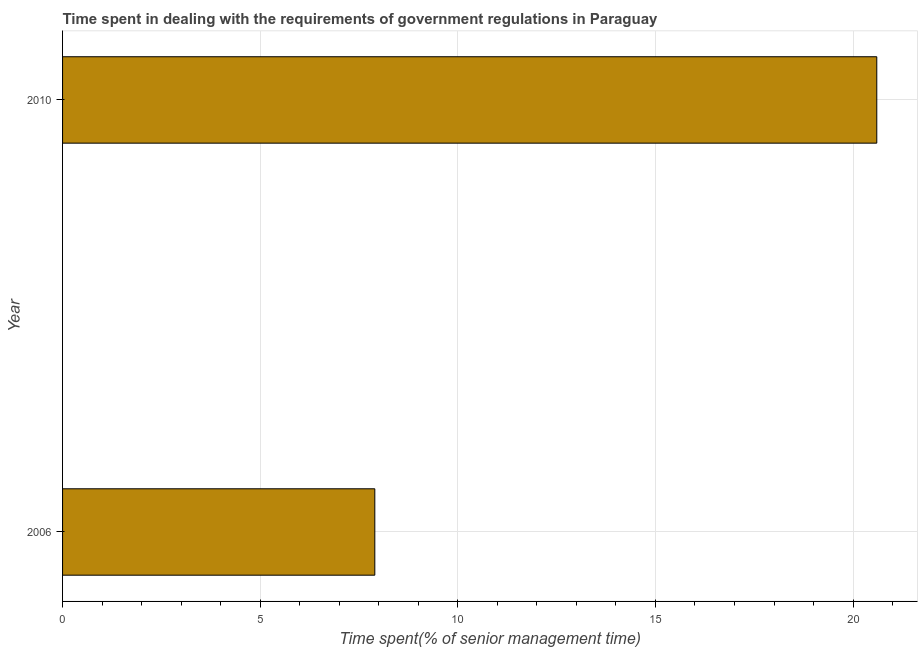What is the title of the graph?
Your answer should be compact. Time spent in dealing with the requirements of government regulations in Paraguay. What is the label or title of the X-axis?
Give a very brief answer. Time spent(% of senior management time). What is the label or title of the Y-axis?
Ensure brevity in your answer.  Year. Across all years, what is the maximum time spent in dealing with government regulations?
Make the answer very short. 20.6. Across all years, what is the minimum time spent in dealing with government regulations?
Ensure brevity in your answer.  7.9. What is the average time spent in dealing with government regulations per year?
Your response must be concise. 14.25. What is the median time spent in dealing with government regulations?
Provide a succinct answer. 14.25. Do a majority of the years between 2006 and 2010 (inclusive) have time spent in dealing with government regulations greater than 9 %?
Your answer should be very brief. No. What is the ratio of the time spent in dealing with government regulations in 2006 to that in 2010?
Offer a very short reply. 0.38. What is the Time spent(% of senior management time) in 2010?
Keep it short and to the point. 20.6. What is the ratio of the Time spent(% of senior management time) in 2006 to that in 2010?
Provide a succinct answer. 0.38. 